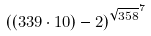<formula> <loc_0><loc_0><loc_500><loc_500>( ( 3 3 9 \cdot 1 0 ) - 2 ) ^ { \sqrt { 3 5 8 } ^ { 7 } }</formula> 